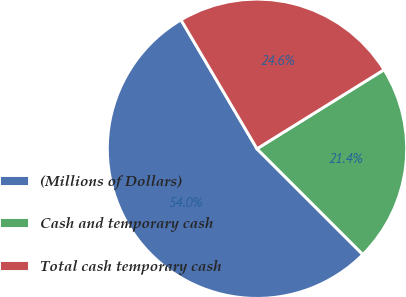<chart> <loc_0><loc_0><loc_500><loc_500><pie_chart><fcel>(Millions of Dollars)<fcel>Cash and temporary cash<fcel>Total cash temporary cash<nl><fcel>54.03%<fcel>21.35%<fcel>24.62%<nl></chart> 